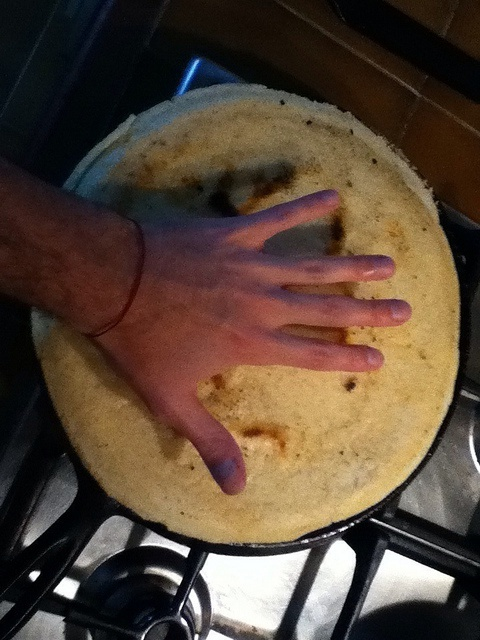Describe the objects in this image and their specific colors. I can see oven in black, tan, and gray tones and people in black, maroon, brown, and purple tones in this image. 